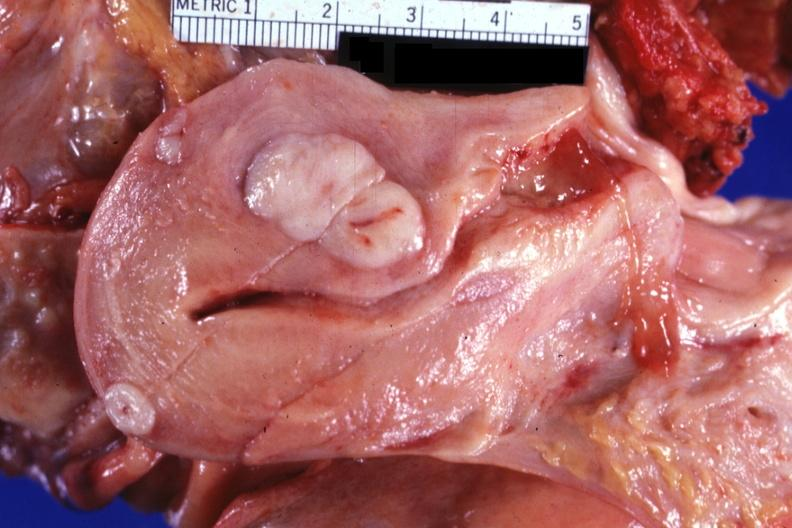s leiomyomas present?
Answer the question using a single word or phrase. Yes 